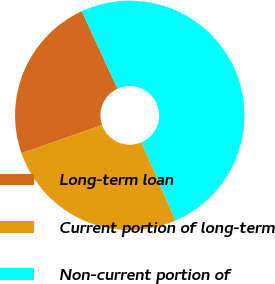Convert chart. <chart><loc_0><loc_0><loc_500><loc_500><pie_chart><fcel>Long-term loan<fcel>Current portion of long-term<fcel>Non-current portion of<nl><fcel>23.49%<fcel>26.18%<fcel>50.33%<nl></chart> 